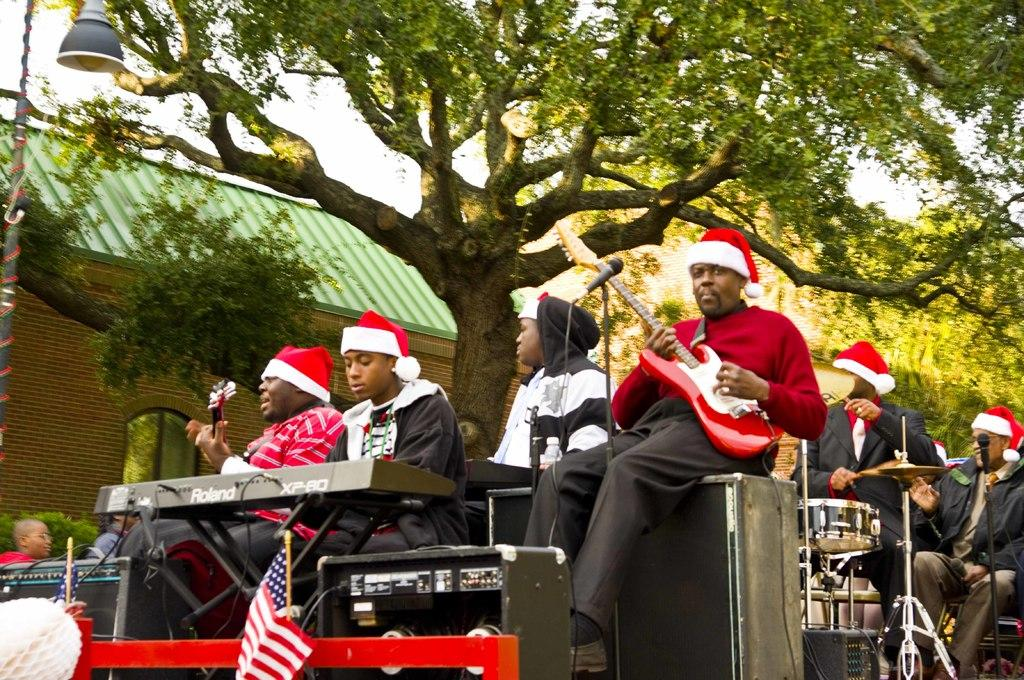How many people are in the image? There is a group of persons in the image. What are the persons in the image doing? The persons are playing musical instruments. What can be seen in the background of the image? There is a tree and a building in the background of the image. What type of comb can be seen in the hands of the person playing the guitar? There is no comb present in the image; the persons are playing musical instruments. On which street is the group of persons performing? The image does not provide information about a street or location, so it cannot be determined. 